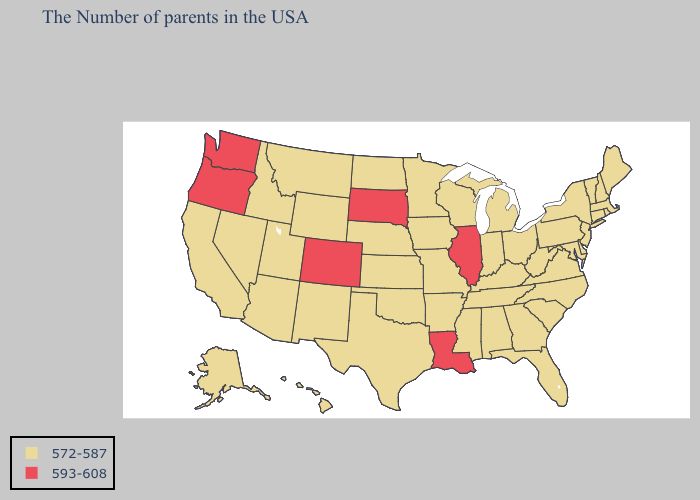Among the states that border Wisconsin , does Illinois have the highest value?
Concise answer only. Yes. Among the states that border Minnesota , does Wisconsin have the highest value?
Give a very brief answer. No. Which states have the lowest value in the Northeast?
Write a very short answer. Maine, Massachusetts, Rhode Island, New Hampshire, Vermont, Connecticut, New York, New Jersey, Pennsylvania. Does Colorado have the lowest value in the West?
Be succinct. No. Among the states that border California , does Arizona have the lowest value?
Be succinct. Yes. What is the value of Delaware?
Quick response, please. 572-587. What is the lowest value in states that border Rhode Island?
Answer briefly. 572-587. What is the highest value in the USA?
Short answer required. 593-608. Which states have the highest value in the USA?
Give a very brief answer. Illinois, Louisiana, South Dakota, Colorado, Washington, Oregon. Name the states that have a value in the range 572-587?
Short answer required. Maine, Massachusetts, Rhode Island, New Hampshire, Vermont, Connecticut, New York, New Jersey, Delaware, Maryland, Pennsylvania, Virginia, North Carolina, South Carolina, West Virginia, Ohio, Florida, Georgia, Michigan, Kentucky, Indiana, Alabama, Tennessee, Wisconsin, Mississippi, Missouri, Arkansas, Minnesota, Iowa, Kansas, Nebraska, Oklahoma, Texas, North Dakota, Wyoming, New Mexico, Utah, Montana, Arizona, Idaho, Nevada, California, Alaska, Hawaii. Name the states that have a value in the range 593-608?
Short answer required. Illinois, Louisiana, South Dakota, Colorado, Washington, Oregon. What is the value of Alaska?
Short answer required. 572-587. Name the states that have a value in the range 572-587?
Give a very brief answer. Maine, Massachusetts, Rhode Island, New Hampshire, Vermont, Connecticut, New York, New Jersey, Delaware, Maryland, Pennsylvania, Virginia, North Carolina, South Carolina, West Virginia, Ohio, Florida, Georgia, Michigan, Kentucky, Indiana, Alabama, Tennessee, Wisconsin, Mississippi, Missouri, Arkansas, Minnesota, Iowa, Kansas, Nebraska, Oklahoma, Texas, North Dakota, Wyoming, New Mexico, Utah, Montana, Arizona, Idaho, Nevada, California, Alaska, Hawaii. What is the value of Wyoming?
Answer briefly. 572-587. 